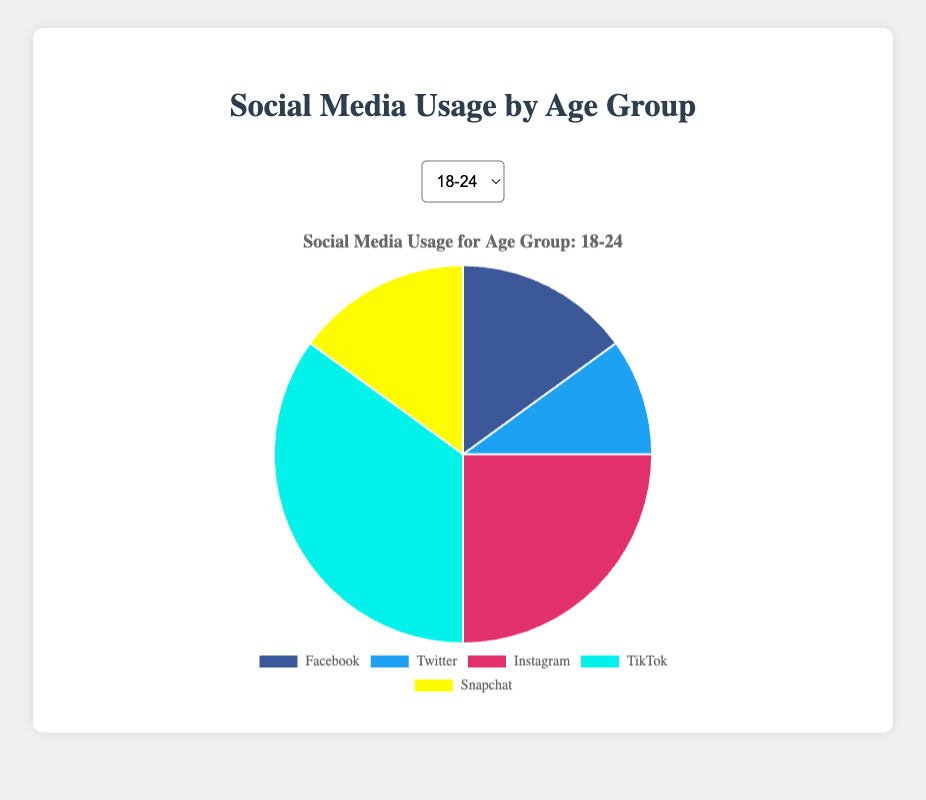Which platform has the highest usage in the 18-24 age group? Referring to the pie chart for the 18-24 age group, TikTok has the largest slice indicating the highest usage.
Answer: TikTok Comparing the age groups 35-44 and 45-54, which one spends more time on Instagram? In the pie chart for the 35-44 age group, Instagram usage is 25%. In the 45-54 age group, Instagram usage is 20%. Therefore, the 35-44 age group spends more time on Instagram.
Answer: 35-44 What is the combined percentage of time spent on Snapchat and Twitter in the 25-34 age group? In the 25-34 age group, time spent on Snapchat is 10% and on Twitter is 15%. Adding these together, 10% + 15% = 25%.
Answer: 25% Which age group has the lowest percentage of time spent on Facebook? In the pie charts for all age groups, the 18-24 age group has the lowest percentage of time spent on Facebook at 15%.
Answer: 18-24 Calculate the difference in TikTok usage between the 18-24 and 55+ age groups. Referring to the pie charts for TikTok usage, the 18-24 age group spends 35% of their time on TikTok, while the 55+ age group spends 10%. The difference is 35% - 10% = 25%.
Answer: 25% Which platform's usage remains constant across three age groups? Analyzing the pie charts, Snapchat usage is constant at 10% for the 35-44, 45-54, and 55+ age groups.
Answer: Snapchat What is the average percentage of time spent on Instagram across all age groups? Summing the Instagram usage percentages: 25% (18-24) + 30% (25-34) + 25% (35-44) + 20% (45-54) + 15% (55+) = 115%. Dividing by the number of age groups (5), the average is 115% / 5 = 23%.
Answer: 23% In the 25-34 age group, which platform is used the least and what is its percentage? Referring to the pie chart for the 25-34 age group, Snapchat has the smallest slice indicating the least usage, which is 10%.
Answer: Snapchat, 10% For the 45-54 age group, how much more time is spent on Facebook compared to TikTok? In the 45-54 age group, Facebook usage is 40% and TikTok usage is 10%. The difference is 40% - 10% = 30%.
Answer: 30% 